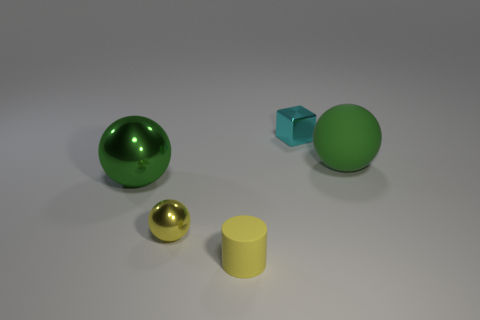Add 4 green metal objects. How many objects exist? 9 Subtract all cylinders. How many objects are left? 4 Add 1 tiny yellow shiny spheres. How many tiny yellow shiny spheres are left? 2 Add 3 green matte cylinders. How many green matte cylinders exist? 3 Subtract 0 yellow cubes. How many objects are left? 5 Subtract all green rubber spheres. Subtract all small yellow metal objects. How many objects are left? 3 